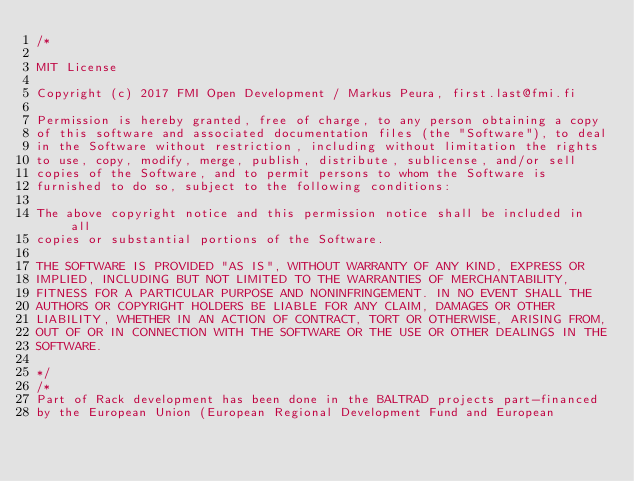Convert code to text. <code><loc_0><loc_0><loc_500><loc_500><_C_>/*

MIT License

Copyright (c) 2017 FMI Open Development / Markus Peura, first.last@fmi.fi

Permission is hereby granted, free of charge, to any person obtaining a copy
of this software and associated documentation files (the "Software"), to deal
in the Software without restriction, including without limitation the rights
to use, copy, modify, merge, publish, distribute, sublicense, and/or sell
copies of the Software, and to permit persons to whom the Software is
furnished to do so, subject to the following conditions:

The above copyright notice and this permission notice shall be included in all
copies or substantial portions of the Software.

THE SOFTWARE IS PROVIDED "AS IS", WITHOUT WARRANTY OF ANY KIND, EXPRESS OR
IMPLIED, INCLUDING BUT NOT LIMITED TO THE WARRANTIES OF MERCHANTABILITY,
FITNESS FOR A PARTICULAR PURPOSE AND NONINFRINGEMENT. IN NO EVENT SHALL THE
AUTHORS OR COPYRIGHT HOLDERS BE LIABLE FOR ANY CLAIM, DAMAGES OR OTHER
LIABILITY, WHETHER IN AN ACTION OF CONTRACT, TORT OR OTHERWISE, ARISING FROM,
OUT OF OR IN CONNECTION WITH THE SOFTWARE OR THE USE OR OTHER DEALINGS IN THE
SOFTWARE.

*/
/*
Part of Rack development has been done in the BALTRAD projects part-financed
by the European Union (European Regional Development Fund and European</code> 